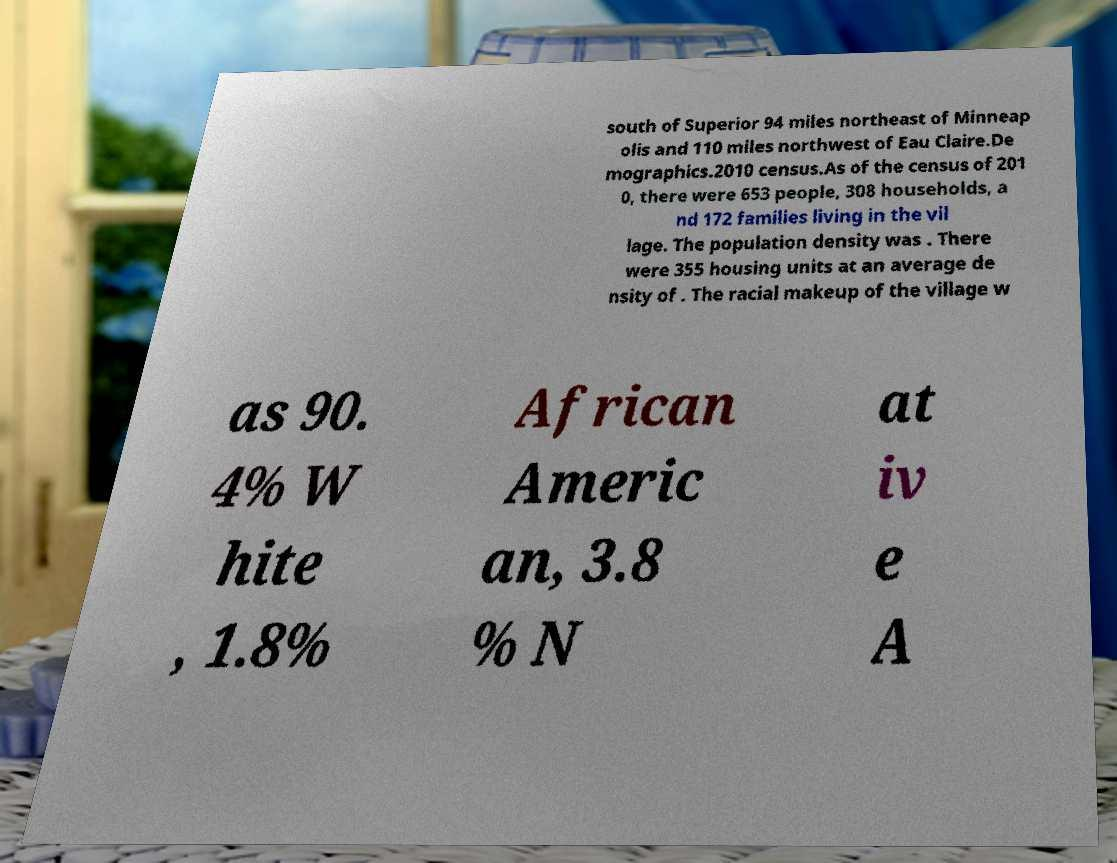What messages or text are displayed in this image? I need them in a readable, typed format. south of Superior 94 miles northeast of Minneap olis and 110 miles northwest of Eau Claire.De mographics.2010 census.As of the census of 201 0, there were 653 people, 308 households, a nd 172 families living in the vil lage. The population density was . There were 355 housing units at an average de nsity of . The racial makeup of the village w as 90. 4% W hite , 1.8% African Americ an, 3.8 % N at iv e A 